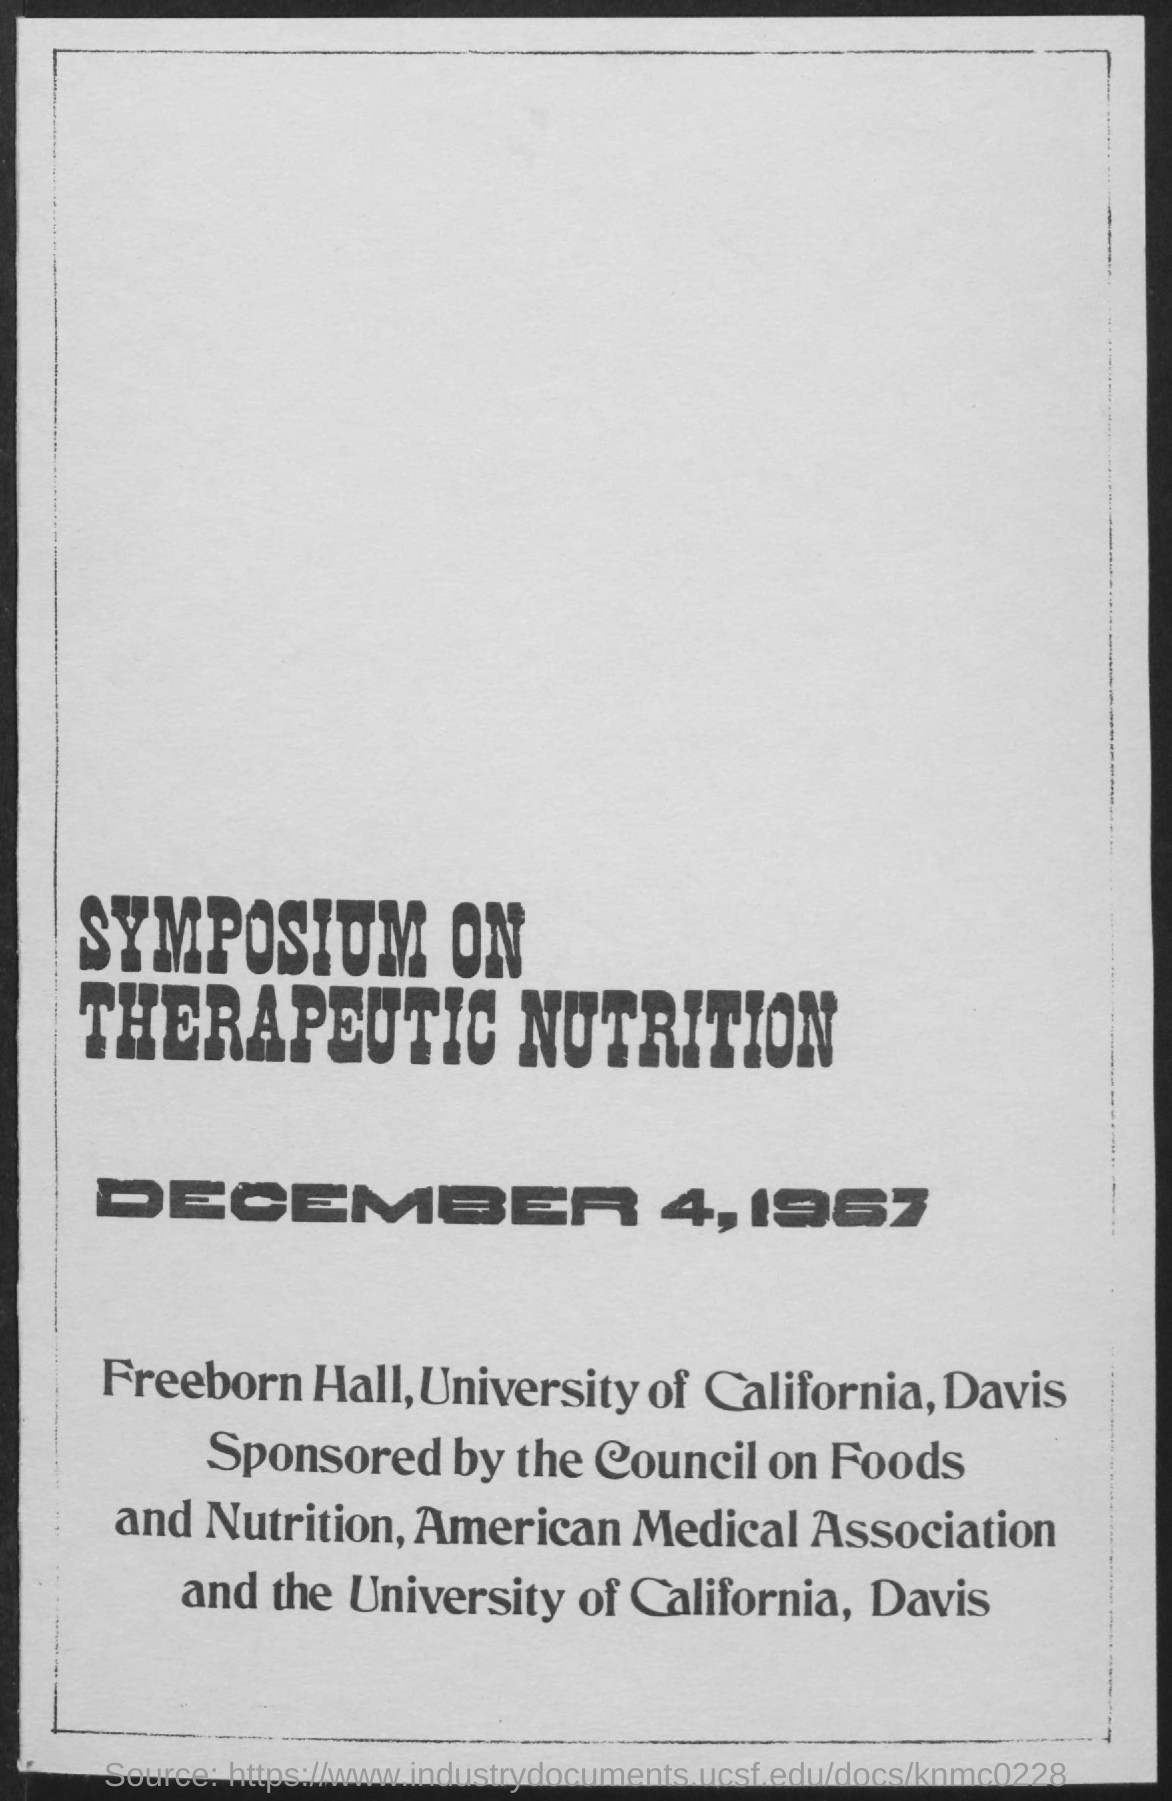Indicate a few pertinent items in this graphic. The document is titled "Symposium on Therapeutic Nutrition. 